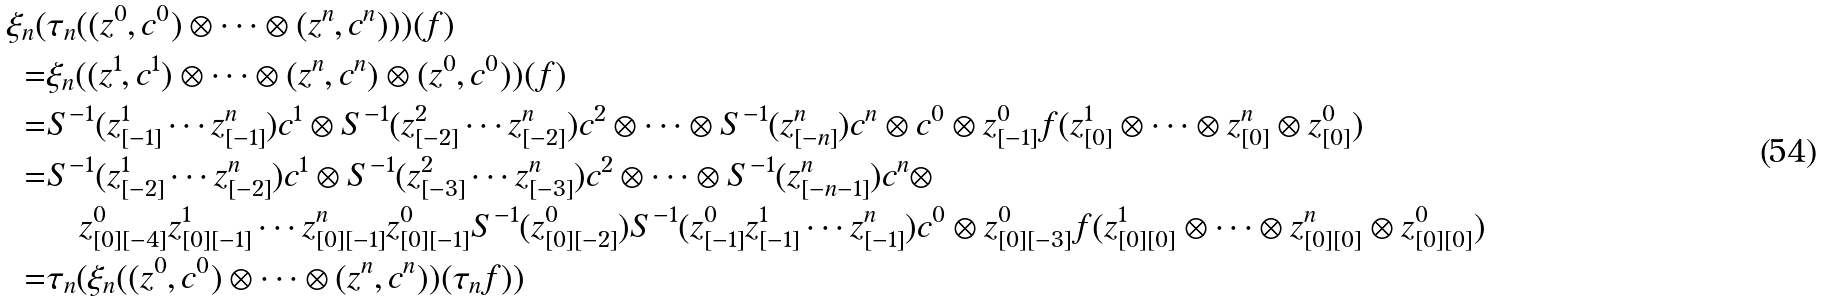<formula> <loc_0><loc_0><loc_500><loc_500>\xi _ { n } ( & \tau _ { n } ( ( z ^ { 0 } , c ^ { 0 } ) \otimes \cdots \otimes ( z ^ { n } , c ^ { n } ) ) ) ( f ) \\ = & \xi _ { n } ( ( z ^ { 1 } , c ^ { 1 } ) \otimes \cdots \otimes ( z ^ { n } , c ^ { n } ) \otimes ( z ^ { 0 } , c ^ { 0 } ) ) ( f ) \\ = & S ^ { - 1 } ( z ^ { 1 } _ { [ - 1 ] } \cdots z ^ { n } _ { [ - 1 ] } ) c ^ { 1 } \otimes S ^ { - 1 } ( z ^ { 2 } _ { [ - 2 ] } \cdots z ^ { n } _ { [ - 2 ] } ) c ^ { 2 } \otimes \cdots \otimes S ^ { - 1 } ( z ^ { n } _ { [ - n ] } ) c ^ { n } \otimes c ^ { 0 } \otimes z ^ { 0 } _ { [ - 1 ] } f ( z ^ { 1 } _ { [ 0 ] } \otimes \cdots \otimes z ^ { n } _ { [ 0 ] } \otimes z ^ { 0 } _ { [ 0 ] } ) \\ = & S ^ { - 1 } ( z ^ { 1 } _ { [ - 2 ] } \cdots z ^ { n } _ { [ - 2 ] } ) c ^ { 1 } \otimes S ^ { - 1 } ( z ^ { 2 } _ { [ - 3 ] } \cdots z ^ { n } _ { [ - 3 ] } ) c ^ { 2 } \otimes \cdots \otimes S ^ { - 1 } ( z ^ { n } _ { [ - n - 1 ] } ) c ^ { n } \otimes \\ & \quad z ^ { 0 } _ { [ 0 ] [ - 4 ] } z ^ { 1 } _ { [ 0 ] [ - 1 ] } \cdots z ^ { n } _ { [ 0 ] [ - 1 ] } z ^ { 0 } _ { [ 0 ] [ - 1 ] } S ^ { - 1 } ( z ^ { 0 } _ { [ 0 ] [ - 2 ] } ) S ^ { - 1 } ( z ^ { 0 } _ { [ - 1 ] } z ^ { 1 } _ { [ - 1 ] } \cdots z ^ { n } _ { [ - 1 ] } ) c ^ { 0 } \otimes z ^ { 0 } _ { [ 0 ] [ - 3 ] } f ( z ^ { 1 } _ { [ 0 ] [ 0 ] } \otimes \cdots \otimes z ^ { n } _ { [ 0 ] [ 0 ] } \otimes z ^ { 0 } _ { [ 0 ] [ 0 ] } ) \\ = & \tau _ { n } ( \xi _ { n } ( ( z ^ { 0 } , c ^ { 0 } ) \otimes \cdots \otimes ( z ^ { n } , c ^ { n } ) ) ( \tau _ { n } f ) )</formula> 